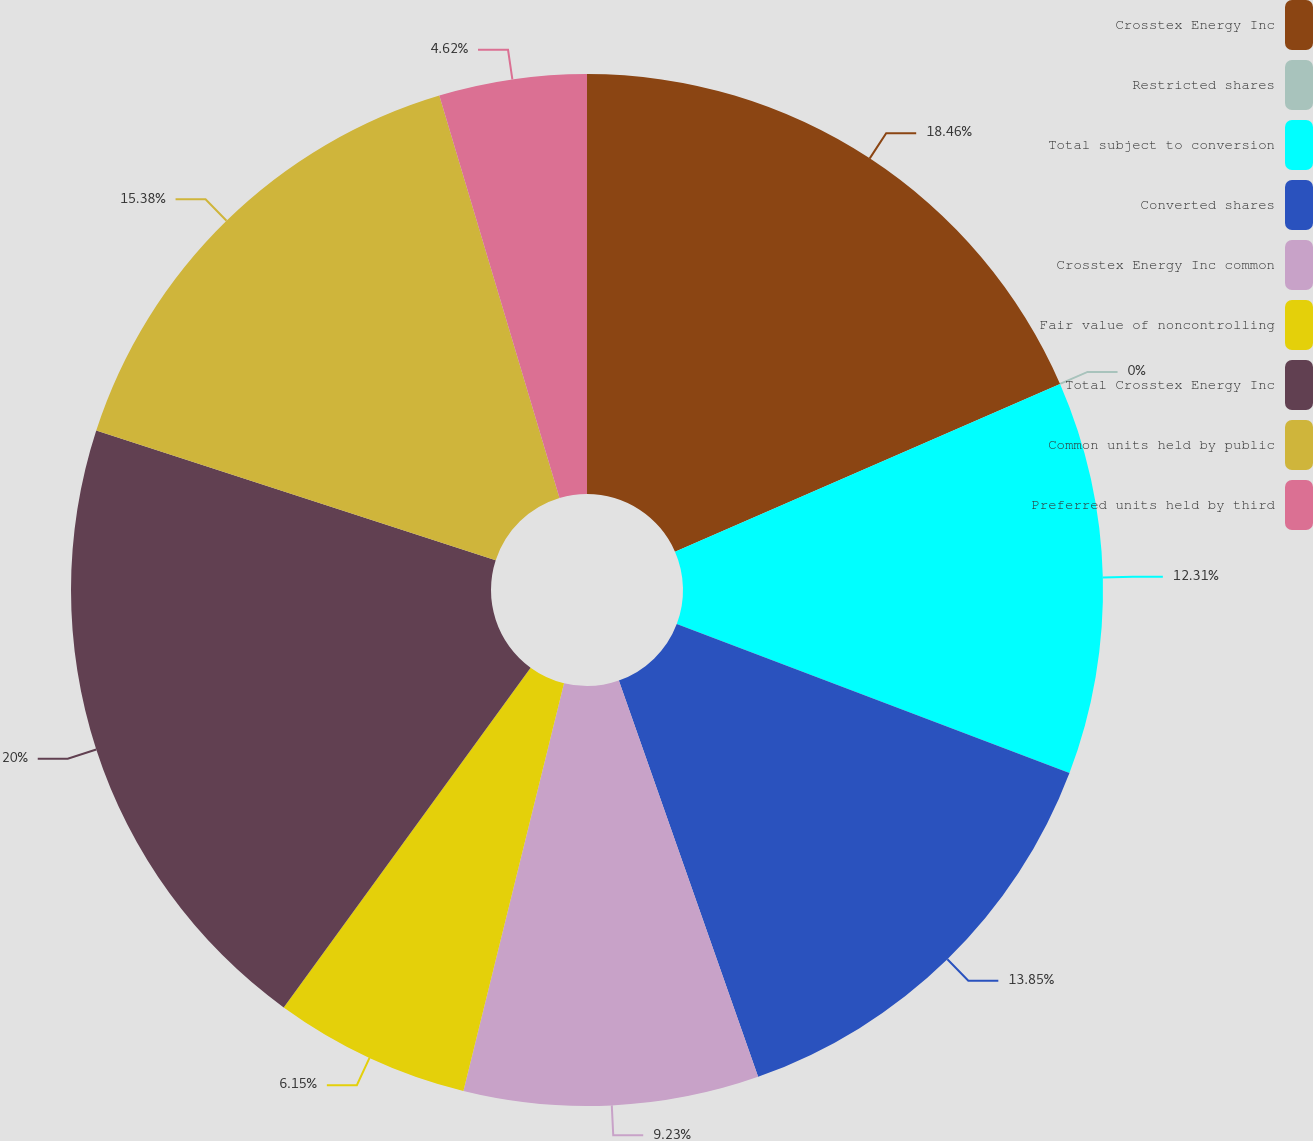Convert chart. <chart><loc_0><loc_0><loc_500><loc_500><pie_chart><fcel>Crosstex Energy Inc<fcel>Restricted shares<fcel>Total subject to conversion<fcel>Converted shares<fcel>Crosstex Energy Inc common<fcel>Fair value of noncontrolling<fcel>Total Crosstex Energy Inc<fcel>Common units held by public<fcel>Preferred units held by third<nl><fcel>18.46%<fcel>0.0%<fcel>12.31%<fcel>13.85%<fcel>9.23%<fcel>6.15%<fcel>20.0%<fcel>15.38%<fcel>4.62%<nl></chart> 